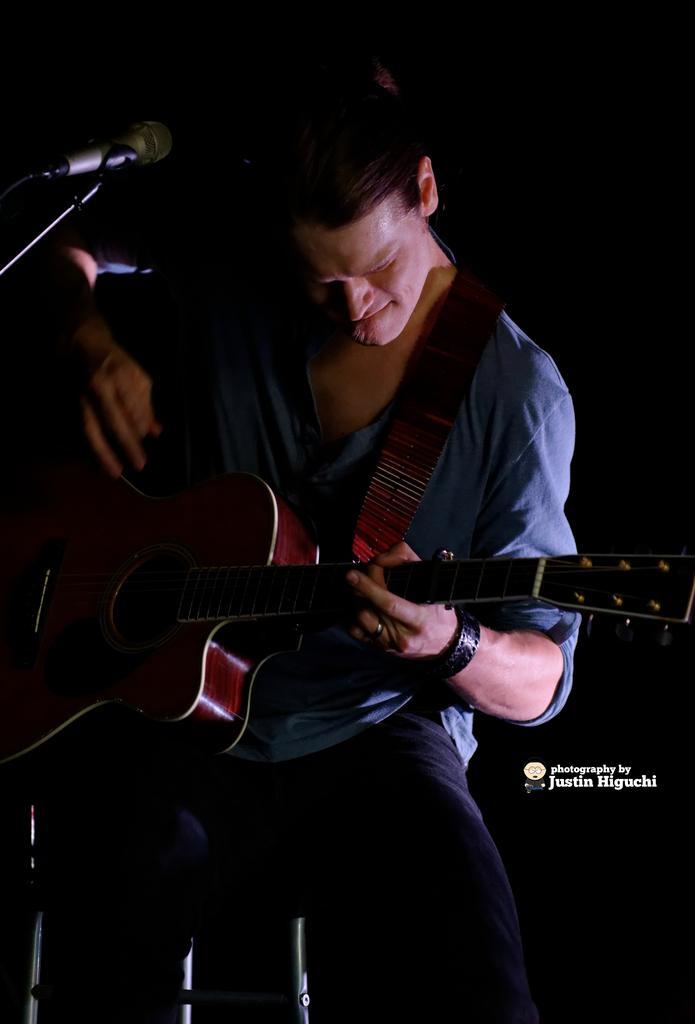Can you describe this image briefly? In this image I see a man who is holding a guitar and there is a mic in front of him. 